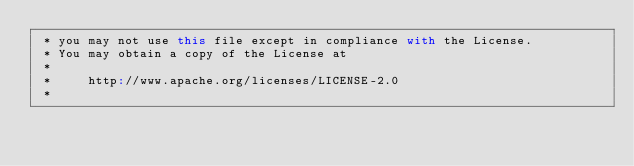Convert code to text. <code><loc_0><loc_0><loc_500><loc_500><_Scala_> * you may not use this file except in compliance with the License.
 * You may obtain a copy of the License at
 *
 *     http://www.apache.org/licenses/LICENSE-2.0
 *</code> 